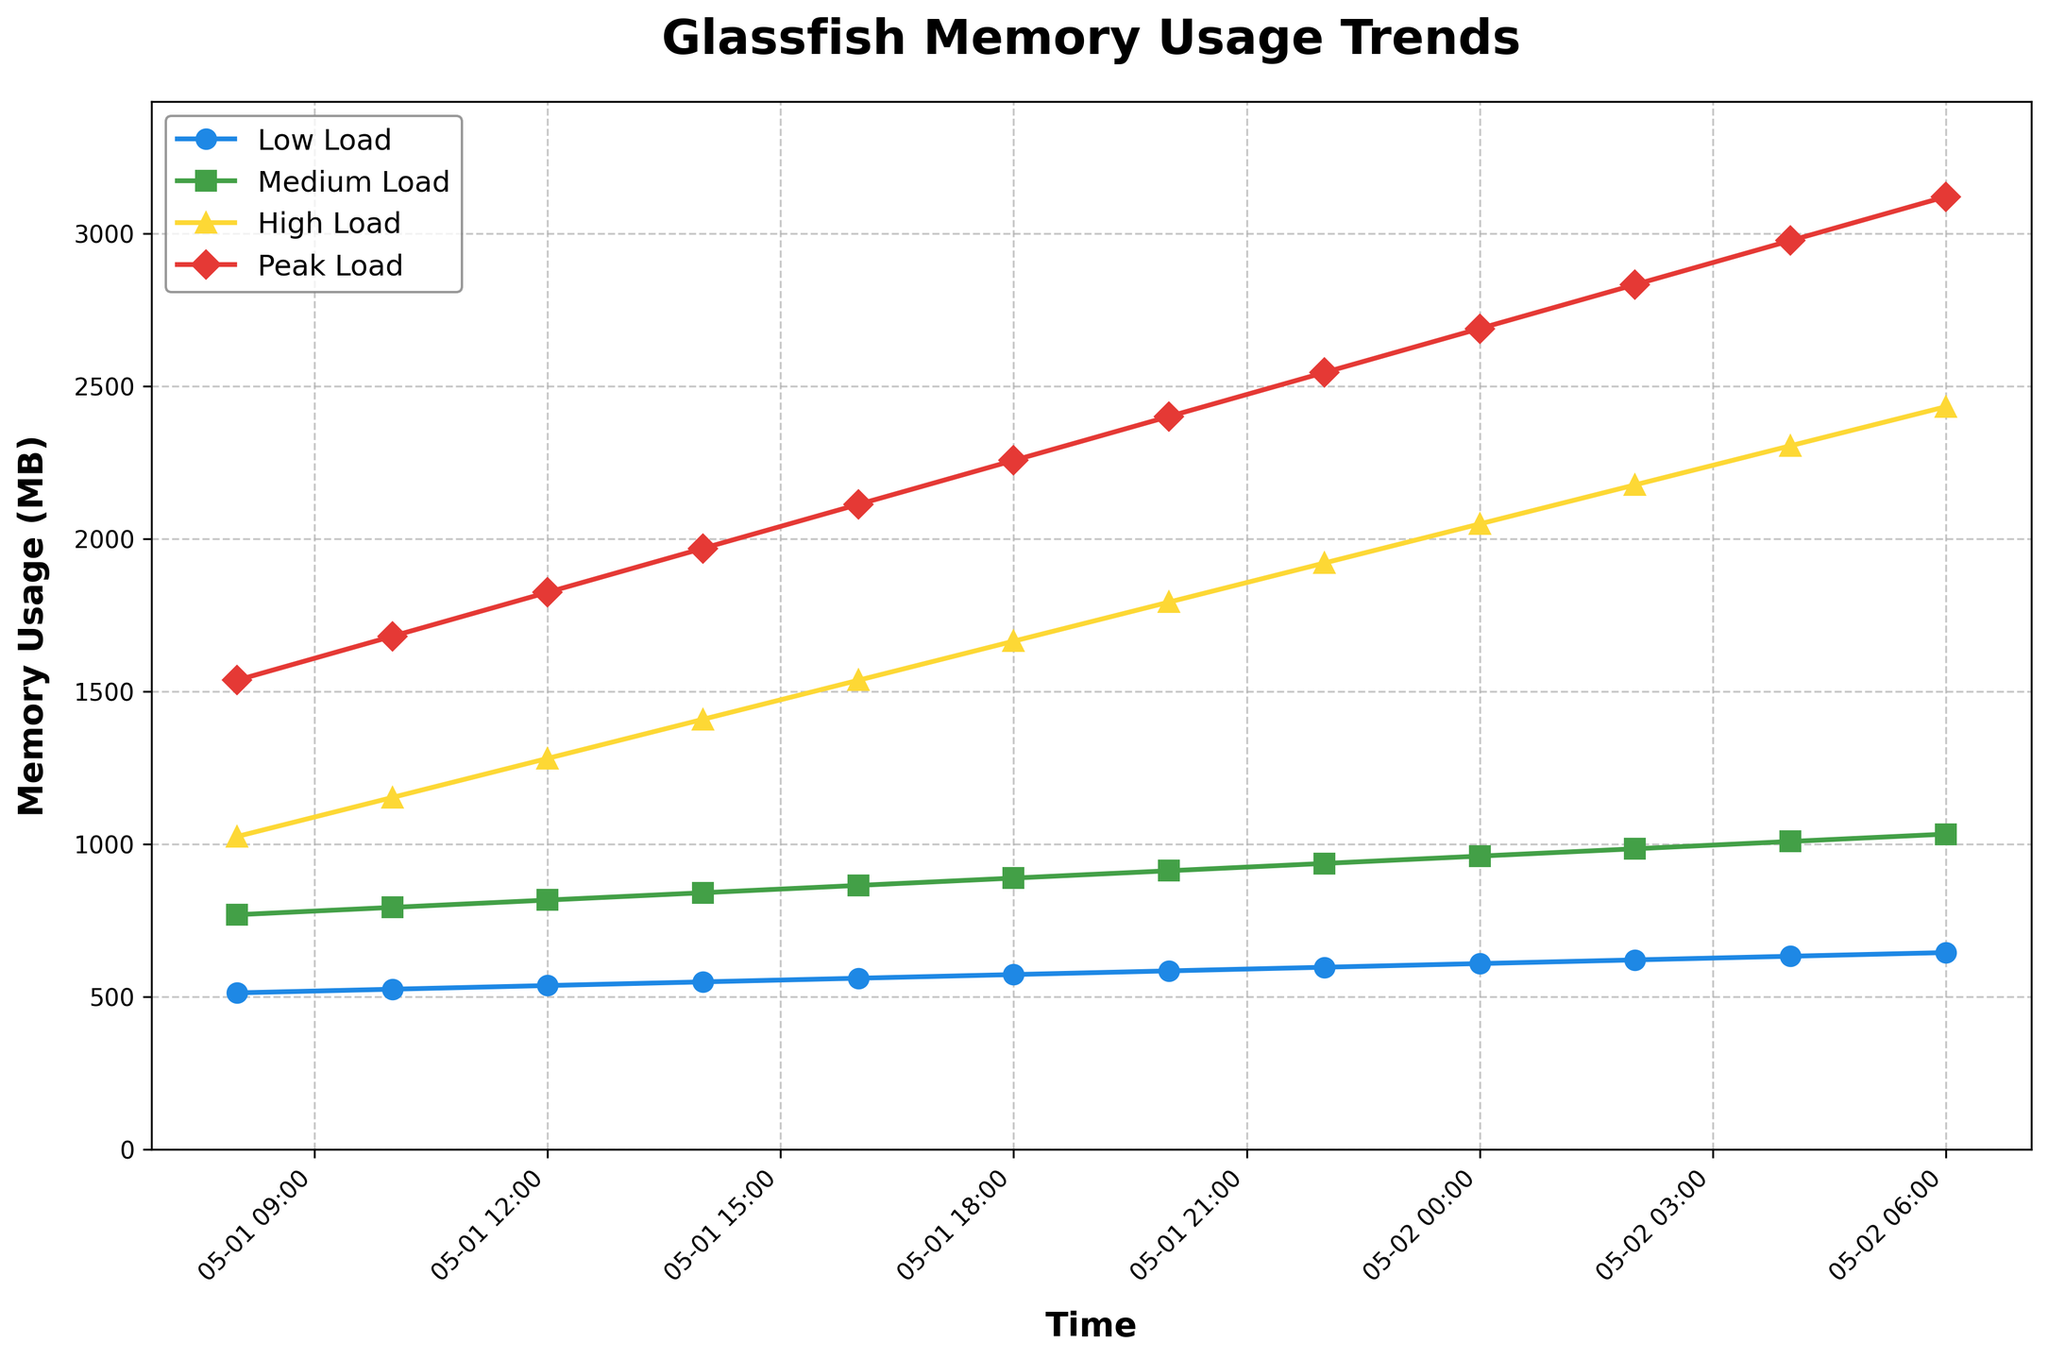What is the overall trend of memory usage for the Low Load throughout the given period? By examining the line representing the Low Load memory usage, it is clear that the memory usage is gradually increasing over time. Starting from 512 MB on May 1, 08:00, to 644 MB on May 2, 06:00, there is a consistent upward trend.
Answer: Gradually increasing How much did the Medium Load memory usage increase from May 1, 08:00 to May 2, 06:00? At May 1, 08:00, the Medium Load memory usage was 768 MB, and at May 2, 06:00, it was 1032 MB. Subtracting the two values gives 1032 - 768 = 264 MB.
Answer: 264 MB Which load condition shows the steepest rise in memory usage over the plotted time period? By observing the slopes of the plotted lines, the Peak Load line shows the steepest rise from its lowest point at 1536 MB to its highest at 3120 MB, indicating it has the highest rate of increase.
Answer: Peak Load At what timestamp does the High Load memory usage cross the 2000 MB mark? By following the High Load line, it crosses the 2000 MB mark sometime between May 2, 00:00 and May 2, 02:00. The exact time looks to be between this range, but is slightly closer to May 2, 02:00.
Answer: May 2, 02:00 Compare the memory usage at May 1, 16:00 for Low Load and High Load. Which one is higher and by how much? At May 1, 16:00, the Low Load memory usage is 560 MB, and the High Load memory usage is 1536 MB. The difference is 1536 - 560 = 976 MB, with High Load being higher.
Answer: High Load by 976 MB What is the average memory usage for Peak Load across the given timestamps? To find the average, sum the memory usage values for Peak Load and divide by the number of timestamps: (1536 + 1680 + 1824 + 1968 + 2112 + 2256 + 2400 + 2544 + 2688 + 2832 + 2976 + 3120) / 12 = 2390 MB.
Answer: 2390 MB Based on the colors, which line represents the Medium Load and how can you tell? The Medium Load line is represented in green and corresponds to the consistently increasing green line. The green color is used distinctively across the plot for clarity in comparison.
Answer: Green line Do any of the load conditions show a constant memory usage without any increments? By examining each plotted line, all load conditions (Low, Medium, High, Peak) show increments in memory usage over time without any flat sections indicating constancy.
Answer: No Which time interval shows the fastest increase in memory usage for the Medium Load? Inspecting the Medium Load green line, the section between May 2, 00:00 and May 2, 02:00, shows the sharpest incline which indicates the fastest increase in this time interval.
Answer: May 2, 00:00 to May 2, 02:00 